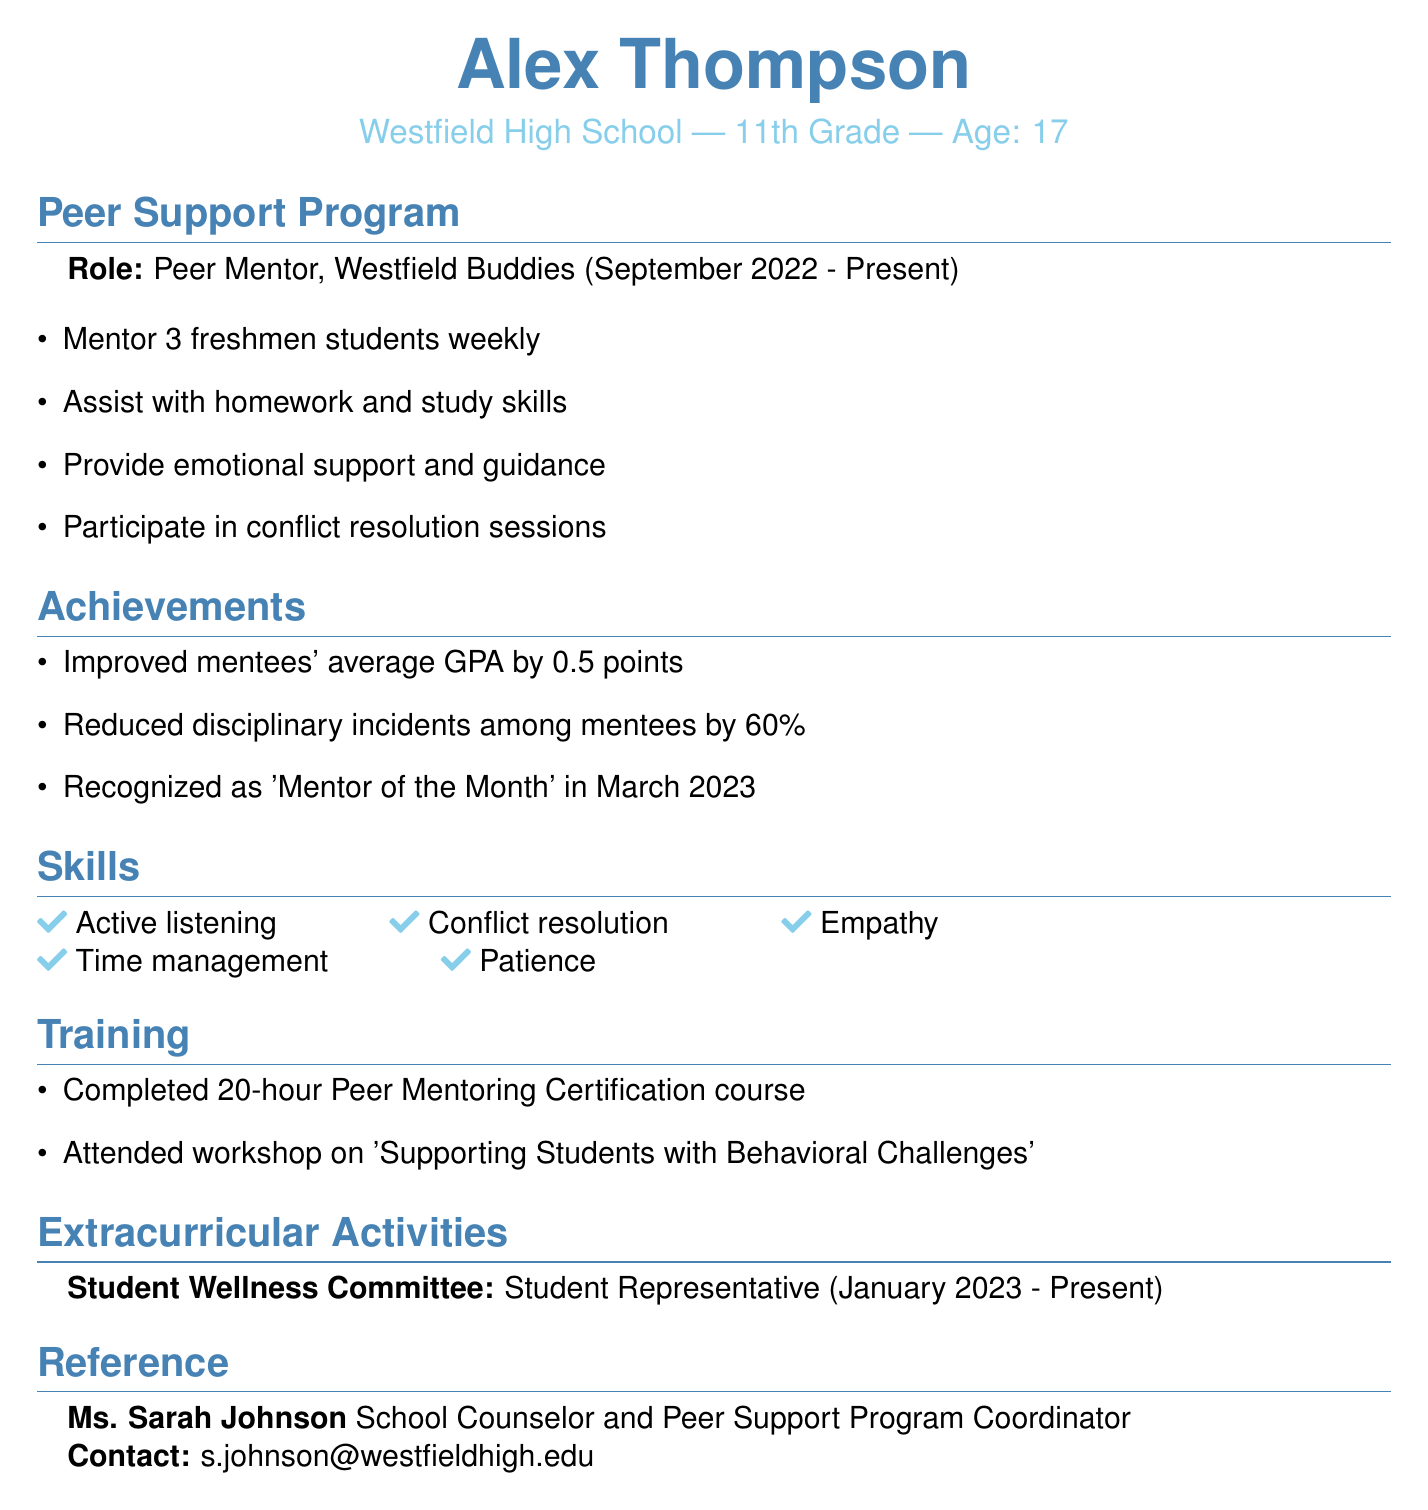What is the name of the peer support program? The name of the peer support program is clearly stated in the document, which is "Westfield Buddies."
Answer: Westfield Buddies What role does Alex have in the program? The document indicates that Alex is a "Peer Mentor" in the program.
Answer: Peer Mentor How many freshmen students does Alex mentor weekly? The document specifies that Alex mentors "3 freshmen students weekly."
Answer: 3 What is the duration of Alex's involvement in the program? The document provides the start date and current status, stating Alex has been involved since "September 2022 - Present."
Answer: September 2022 - Present What achievement is noted for improving mentees' GPA? The document mentions that Alex "Improved mentees' average GPA by 0.5 points."
Answer: 0.5 points Which skill related to supporting others does Alex list? The document lists various skills, and one of them is "Empathy."
Answer: Empathy Who is the reference contact in the document? The document provides the name of the reference contact as "Ms. Sarah Johnson."
Answer: Ms. Sarah Johnson What is one of the training sessions Alex attended? The document mentions attendance at a workshop titled "Supporting Students with Behavioral Challenges."
Answer: Supporting Students with Behavioral Challenges What extracurricular committee is Alex a member of? The document states that Alex is a "Member of Student Wellness Committee."
Answer: Student Wellness Committee 